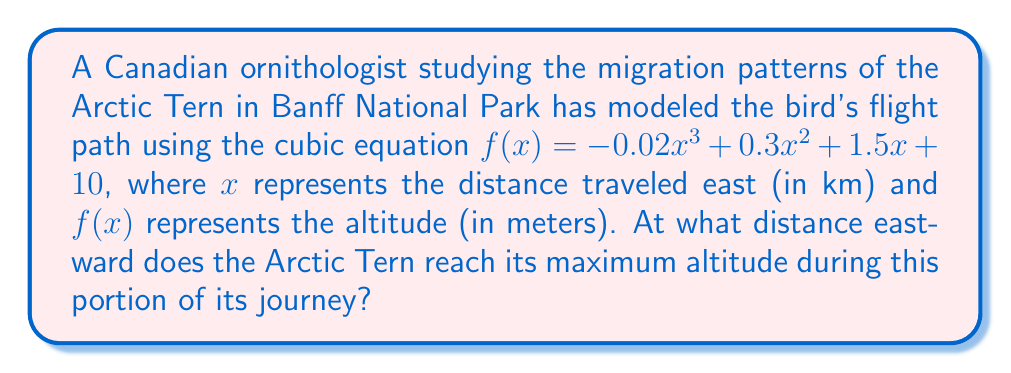Teach me how to tackle this problem. To find the maximum altitude, we need to determine where the derivative of the function equals zero. This will give us the x-coordinate of the turning point.

1) First, let's find the derivative of $f(x)$:
   $f'(x) = -0.06x^2 + 0.6x + 1.5$

2) Set $f'(x) = 0$ and solve for $x$:
   $-0.06x^2 + 0.6x + 1.5 = 0$

3) This is a quadratic equation. We can solve it using the quadratic formula:
   $x = \frac{-b \pm \sqrt{b^2 - 4ac}}{2a}$

   Where $a = -0.06$, $b = 0.6$, and $c = 1.5$

4) Substituting these values:
   $x = \frac{-0.6 \pm \sqrt{0.6^2 - 4(-0.06)(1.5)}}{2(-0.06)}$

5) Simplifying:
   $x = \frac{-0.6 \pm \sqrt{0.36 + 0.36}}{-0.12} = \frac{-0.6 \pm \sqrt{0.72}}{-0.12} = \frac{-0.6 \pm 0.8485}{-0.12}$

6) This gives us two solutions:
   $x_1 = \frac{-0.6 + 0.8485}{-0.12} \approx 2.07$
   $x_2 = \frac{-0.6 - 0.8485}{-0.12} \approx 12.07$

7) To determine which solution gives the maximum (rather than minimum) altitude, we can check the second derivative:
   $f''(x) = -0.12x + 0.6$

8) At $x = 2.07$, $f''(2.07) = 0.3516 > 0$, indicating a local minimum.
   At $x = 12.07$, $f''(12.07) = -0.8484 < 0$, indicating a local maximum.

Therefore, the maximum altitude occurs when $x \approx 12.07$ km east.
Answer: 12.07 km 